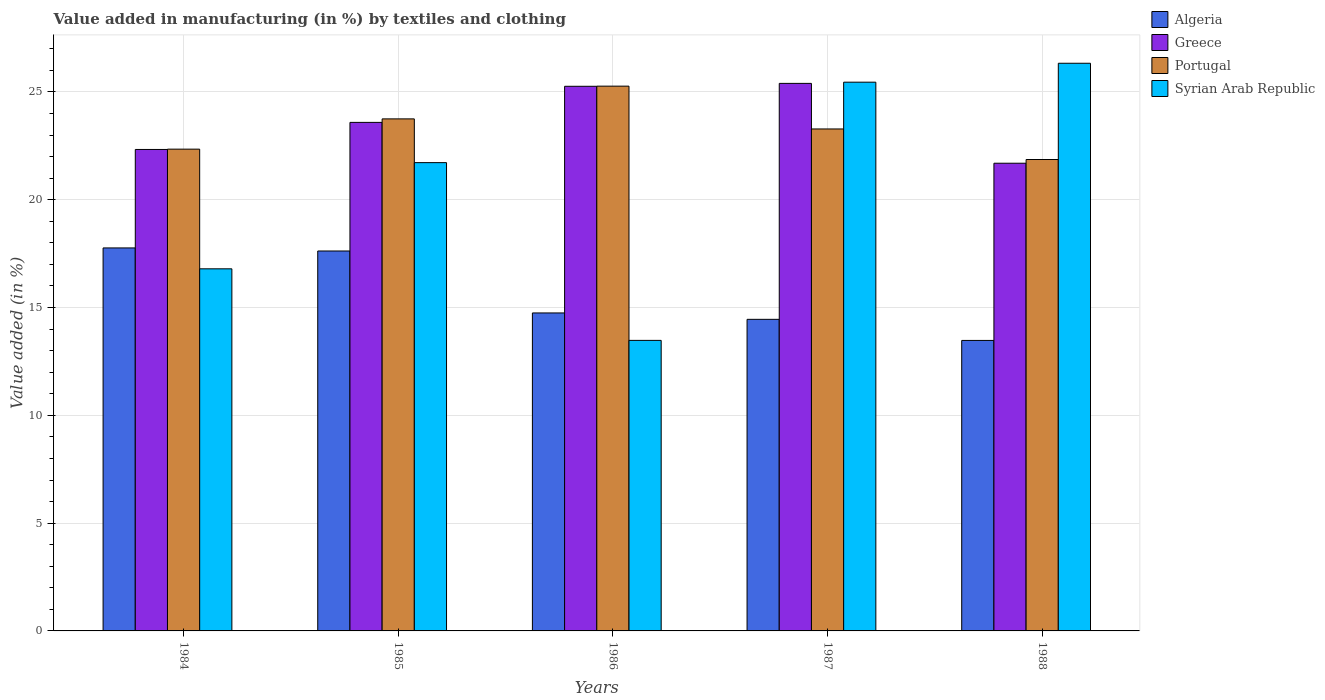How many different coloured bars are there?
Offer a terse response. 4. How many groups of bars are there?
Make the answer very short. 5. Are the number of bars on each tick of the X-axis equal?
Your answer should be compact. Yes. How many bars are there on the 4th tick from the left?
Give a very brief answer. 4. In how many cases, is the number of bars for a given year not equal to the number of legend labels?
Give a very brief answer. 0. What is the percentage of value added in manufacturing by textiles and clothing in Syrian Arab Republic in 1987?
Your answer should be compact. 25.45. Across all years, what is the maximum percentage of value added in manufacturing by textiles and clothing in Greece?
Offer a very short reply. 25.4. Across all years, what is the minimum percentage of value added in manufacturing by textiles and clothing in Greece?
Make the answer very short. 21.69. What is the total percentage of value added in manufacturing by textiles and clothing in Portugal in the graph?
Ensure brevity in your answer.  116.52. What is the difference between the percentage of value added in manufacturing by textiles and clothing in Portugal in 1985 and that in 1987?
Your answer should be very brief. 0.47. What is the difference between the percentage of value added in manufacturing by textiles and clothing in Greece in 1988 and the percentage of value added in manufacturing by textiles and clothing in Algeria in 1987?
Your answer should be compact. 7.24. What is the average percentage of value added in manufacturing by textiles and clothing in Syrian Arab Republic per year?
Make the answer very short. 20.76. In the year 1986, what is the difference between the percentage of value added in manufacturing by textiles and clothing in Greece and percentage of value added in manufacturing by textiles and clothing in Portugal?
Offer a very short reply. -0.01. In how many years, is the percentage of value added in manufacturing by textiles and clothing in Portugal greater than 18 %?
Offer a very short reply. 5. What is the ratio of the percentage of value added in manufacturing by textiles and clothing in Algeria in 1984 to that in 1988?
Your answer should be compact. 1.32. Is the difference between the percentage of value added in manufacturing by textiles and clothing in Greece in 1986 and 1988 greater than the difference between the percentage of value added in manufacturing by textiles and clothing in Portugal in 1986 and 1988?
Your response must be concise. Yes. What is the difference between the highest and the second highest percentage of value added in manufacturing by textiles and clothing in Portugal?
Your response must be concise. 1.52. What is the difference between the highest and the lowest percentage of value added in manufacturing by textiles and clothing in Greece?
Offer a very short reply. 3.7. In how many years, is the percentage of value added in manufacturing by textiles and clothing in Greece greater than the average percentage of value added in manufacturing by textiles and clothing in Greece taken over all years?
Make the answer very short. 2. What does the 3rd bar from the right in 1988 represents?
Keep it short and to the point. Greece. Is it the case that in every year, the sum of the percentage of value added in manufacturing by textiles and clothing in Portugal and percentage of value added in manufacturing by textiles and clothing in Greece is greater than the percentage of value added in manufacturing by textiles and clothing in Syrian Arab Republic?
Your answer should be very brief. Yes. Are all the bars in the graph horizontal?
Offer a very short reply. No. Where does the legend appear in the graph?
Give a very brief answer. Top right. What is the title of the graph?
Offer a very short reply. Value added in manufacturing (in %) by textiles and clothing. Does "Central Europe" appear as one of the legend labels in the graph?
Provide a succinct answer. No. What is the label or title of the X-axis?
Ensure brevity in your answer.  Years. What is the label or title of the Y-axis?
Offer a terse response. Value added (in %). What is the Value added (in %) in Algeria in 1984?
Ensure brevity in your answer.  17.76. What is the Value added (in %) in Greece in 1984?
Give a very brief answer. 22.33. What is the Value added (in %) in Portugal in 1984?
Your answer should be compact. 22.35. What is the Value added (in %) of Syrian Arab Republic in 1984?
Provide a short and direct response. 16.8. What is the Value added (in %) of Algeria in 1985?
Offer a terse response. 17.62. What is the Value added (in %) in Greece in 1985?
Make the answer very short. 23.59. What is the Value added (in %) in Portugal in 1985?
Keep it short and to the point. 23.75. What is the Value added (in %) of Syrian Arab Republic in 1985?
Your answer should be compact. 21.72. What is the Value added (in %) of Algeria in 1986?
Provide a short and direct response. 14.75. What is the Value added (in %) in Greece in 1986?
Make the answer very short. 25.26. What is the Value added (in %) of Portugal in 1986?
Keep it short and to the point. 25.27. What is the Value added (in %) of Syrian Arab Republic in 1986?
Your answer should be very brief. 13.48. What is the Value added (in %) in Algeria in 1987?
Ensure brevity in your answer.  14.45. What is the Value added (in %) of Greece in 1987?
Offer a terse response. 25.4. What is the Value added (in %) of Portugal in 1987?
Offer a terse response. 23.28. What is the Value added (in %) of Syrian Arab Republic in 1987?
Offer a very short reply. 25.45. What is the Value added (in %) of Algeria in 1988?
Your answer should be very brief. 13.47. What is the Value added (in %) of Greece in 1988?
Your answer should be very brief. 21.69. What is the Value added (in %) in Portugal in 1988?
Ensure brevity in your answer.  21.87. What is the Value added (in %) of Syrian Arab Republic in 1988?
Keep it short and to the point. 26.33. Across all years, what is the maximum Value added (in %) in Algeria?
Keep it short and to the point. 17.76. Across all years, what is the maximum Value added (in %) of Greece?
Keep it short and to the point. 25.4. Across all years, what is the maximum Value added (in %) of Portugal?
Make the answer very short. 25.27. Across all years, what is the maximum Value added (in %) in Syrian Arab Republic?
Provide a succinct answer. 26.33. Across all years, what is the minimum Value added (in %) of Algeria?
Provide a succinct answer. 13.47. Across all years, what is the minimum Value added (in %) of Greece?
Provide a succinct answer. 21.69. Across all years, what is the minimum Value added (in %) of Portugal?
Make the answer very short. 21.87. Across all years, what is the minimum Value added (in %) of Syrian Arab Republic?
Offer a very short reply. 13.48. What is the total Value added (in %) in Algeria in the graph?
Provide a succinct answer. 78.06. What is the total Value added (in %) of Greece in the graph?
Your answer should be compact. 118.27. What is the total Value added (in %) in Portugal in the graph?
Keep it short and to the point. 116.52. What is the total Value added (in %) of Syrian Arab Republic in the graph?
Offer a very short reply. 103.78. What is the difference between the Value added (in %) in Algeria in 1984 and that in 1985?
Make the answer very short. 0.14. What is the difference between the Value added (in %) of Greece in 1984 and that in 1985?
Ensure brevity in your answer.  -1.26. What is the difference between the Value added (in %) of Portugal in 1984 and that in 1985?
Offer a very short reply. -1.4. What is the difference between the Value added (in %) of Syrian Arab Republic in 1984 and that in 1985?
Provide a succinct answer. -4.93. What is the difference between the Value added (in %) of Algeria in 1984 and that in 1986?
Give a very brief answer. 3.02. What is the difference between the Value added (in %) in Greece in 1984 and that in 1986?
Your response must be concise. -2.93. What is the difference between the Value added (in %) of Portugal in 1984 and that in 1986?
Provide a short and direct response. -2.92. What is the difference between the Value added (in %) in Syrian Arab Republic in 1984 and that in 1986?
Keep it short and to the point. 3.32. What is the difference between the Value added (in %) in Algeria in 1984 and that in 1987?
Provide a succinct answer. 3.31. What is the difference between the Value added (in %) of Greece in 1984 and that in 1987?
Your answer should be compact. -3.06. What is the difference between the Value added (in %) of Portugal in 1984 and that in 1987?
Ensure brevity in your answer.  -0.94. What is the difference between the Value added (in %) of Syrian Arab Republic in 1984 and that in 1987?
Keep it short and to the point. -8.66. What is the difference between the Value added (in %) of Algeria in 1984 and that in 1988?
Your answer should be very brief. 4.29. What is the difference between the Value added (in %) in Greece in 1984 and that in 1988?
Provide a succinct answer. 0.64. What is the difference between the Value added (in %) of Portugal in 1984 and that in 1988?
Ensure brevity in your answer.  0.48. What is the difference between the Value added (in %) of Syrian Arab Republic in 1984 and that in 1988?
Ensure brevity in your answer.  -9.53. What is the difference between the Value added (in %) of Algeria in 1985 and that in 1986?
Your response must be concise. 2.87. What is the difference between the Value added (in %) in Greece in 1985 and that in 1986?
Offer a very short reply. -1.67. What is the difference between the Value added (in %) in Portugal in 1985 and that in 1986?
Your answer should be very brief. -1.52. What is the difference between the Value added (in %) in Syrian Arab Republic in 1985 and that in 1986?
Provide a short and direct response. 8.24. What is the difference between the Value added (in %) in Algeria in 1985 and that in 1987?
Your answer should be very brief. 3.17. What is the difference between the Value added (in %) of Greece in 1985 and that in 1987?
Keep it short and to the point. -1.81. What is the difference between the Value added (in %) of Portugal in 1985 and that in 1987?
Make the answer very short. 0.47. What is the difference between the Value added (in %) of Syrian Arab Republic in 1985 and that in 1987?
Your response must be concise. -3.73. What is the difference between the Value added (in %) of Algeria in 1985 and that in 1988?
Provide a succinct answer. 4.15. What is the difference between the Value added (in %) of Greece in 1985 and that in 1988?
Your answer should be compact. 1.89. What is the difference between the Value added (in %) in Portugal in 1985 and that in 1988?
Offer a very short reply. 1.88. What is the difference between the Value added (in %) of Syrian Arab Republic in 1985 and that in 1988?
Your answer should be compact. -4.61. What is the difference between the Value added (in %) in Algeria in 1986 and that in 1987?
Keep it short and to the point. 0.3. What is the difference between the Value added (in %) of Greece in 1986 and that in 1987?
Offer a very short reply. -0.13. What is the difference between the Value added (in %) of Portugal in 1986 and that in 1987?
Provide a succinct answer. 1.99. What is the difference between the Value added (in %) in Syrian Arab Republic in 1986 and that in 1987?
Your response must be concise. -11.98. What is the difference between the Value added (in %) in Algeria in 1986 and that in 1988?
Offer a terse response. 1.27. What is the difference between the Value added (in %) of Greece in 1986 and that in 1988?
Give a very brief answer. 3.57. What is the difference between the Value added (in %) in Portugal in 1986 and that in 1988?
Your answer should be very brief. 3.4. What is the difference between the Value added (in %) of Syrian Arab Republic in 1986 and that in 1988?
Your answer should be compact. -12.85. What is the difference between the Value added (in %) of Algeria in 1987 and that in 1988?
Your answer should be very brief. 0.98. What is the difference between the Value added (in %) in Greece in 1987 and that in 1988?
Give a very brief answer. 3.7. What is the difference between the Value added (in %) of Portugal in 1987 and that in 1988?
Give a very brief answer. 1.42. What is the difference between the Value added (in %) in Syrian Arab Republic in 1987 and that in 1988?
Offer a terse response. -0.88. What is the difference between the Value added (in %) in Algeria in 1984 and the Value added (in %) in Greece in 1985?
Offer a terse response. -5.82. What is the difference between the Value added (in %) in Algeria in 1984 and the Value added (in %) in Portugal in 1985?
Offer a very short reply. -5.99. What is the difference between the Value added (in %) in Algeria in 1984 and the Value added (in %) in Syrian Arab Republic in 1985?
Provide a succinct answer. -3.96. What is the difference between the Value added (in %) of Greece in 1984 and the Value added (in %) of Portugal in 1985?
Offer a terse response. -1.42. What is the difference between the Value added (in %) in Greece in 1984 and the Value added (in %) in Syrian Arab Republic in 1985?
Make the answer very short. 0.61. What is the difference between the Value added (in %) in Portugal in 1984 and the Value added (in %) in Syrian Arab Republic in 1985?
Keep it short and to the point. 0.63. What is the difference between the Value added (in %) in Algeria in 1984 and the Value added (in %) in Greece in 1986?
Provide a succinct answer. -7.5. What is the difference between the Value added (in %) in Algeria in 1984 and the Value added (in %) in Portugal in 1986?
Offer a terse response. -7.5. What is the difference between the Value added (in %) in Algeria in 1984 and the Value added (in %) in Syrian Arab Republic in 1986?
Give a very brief answer. 4.29. What is the difference between the Value added (in %) in Greece in 1984 and the Value added (in %) in Portugal in 1986?
Give a very brief answer. -2.94. What is the difference between the Value added (in %) in Greece in 1984 and the Value added (in %) in Syrian Arab Republic in 1986?
Ensure brevity in your answer.  8.86. What is the difference between the Value added (in %) of Portugal in 1984 and the Value added (in %) of Syrian Arab Republic in 1986?
Keep it short and to the point. 8.87. What is the difference between the Value added (in %) of Algeria in 1984 and the Value added (in %) of Greece in 1987?
Give a very brief answer. -7.63. What is the difference between the Value added (in %) in Algeria in 1984 and the Value added (in %) in Portugal in 1987?
Ensure brevity in your answer.  -5.52. What is the difference between the Value added (in %) in Algeria in 1984 and the Value added (in %) in Syrian Arab Republic in 1987?
Your answer should be compact. -7.69. What is the difference between the Value added (in %) in Greece in 1984 and the Value added (in %) in Portugal in 1987?
Ensure brevity in your answer.  -0.95. What is the difference between the Value added (in %) of Greece in 1984 and the Value added (in %) of Syrian Arab Republic in 1987?
Keep it short and to the point. -3.12. What is the difference between the Value added (in %) in Portugal in 1984 and the Value added (in %) in Syrian Arab Republic in 1987?
Keep it short and to the point. -3.11. What is the difference between the Value added (in %) of Algeria in 1984 and the Value added (in %) of Greece in 1988?
Ensure brevity in your answer.  -3.93. What is the difference between the Value added (in %) in Algeria in 1984 and the Value added (in %) in Portugal in 1988?
Make the answer very short. -4.1. What is the difference between the Value added (in %) in Algeria in 1984 and the Value added (in %) in Syrian Arab Republic in 1988?
Offer a very short reply. -8.57. What is the difference between the Value added (in %) of Greece in 1984 and the Value added (in %) of Portugal in 1988?
Give a very brief answer. 0.47. What is the difference between the Value added (in %) in Greece in 1984 and the Value added (in %) in Syrian Arab Republic in 1988?
Your answer should be very brief. -4. What is the difference between the Value added (in %) of Portugal in 1984 and the Value added (in %) of Syrian Arab Republic in 1988?
Your answer should be very brief. -3.98. What is the difference between the Value added (in %) in Algeria in 1985 and the Value added (in %) in Greece in 1986?
Your response must be concise. -7.64. What is the difference between the Value added (in %) in Algeria in 1985 and the Value added (in %) in Portugal in 1986?
Keep it short and to the point. -7.65. What is the difference between the Value added (in %) of Algeria in 1985 and the Value added (in %) of Syrian Arab Republic in 1986?
Provide a succinct answer. 4.15. What is the difference between the Value added (in %) of Greece in 1985 and the Value added (in %) of Portugal in 1986?
Give a very brief answer. -1.68. What is the difference between the Value added (in %) of Greece in 1985 and the Value added (in %) of Syrian Arab Republic in 1986?
Provide a short and direct response. 10.11. What is the difference between the Value added (in %) of Portugal in 1985 and the Value added (in %) of Syrian Arab Republic in 1986?
Ensure brevity in your answer.  10.27. What is the difference between the Value added (in %) in Algeria in 1985 and the Value added (in %) in Greece in 1987?
Ensure brevity in your answer.  -7.77. What is the difference between the Value added (in %) in Algeria in 1985 and the Value added (in %) in Portugal in 1987?
Offer a terse response. -5.66. What is the difference between the Value added (in %) of Algeria in 1985 and the Value added (in %) of Syrian Arab Republic in 1987?
Provide a succinct answer. -7.83. What is the difference between the Value added (in %) of Greece in 1985 and the Value added (in %) of Portugal in 1987?
Your answer should be compact. 0.3. What is the difference between the Value added (in %) of Greece in 1985 and the Value added (in %) of Syrian Arab Republic in 1987?
Your response must be concise. -1.86. What is the difference between the Value added (in %) of Portugal in 1985 and the Value added (in %) of Syrian Arab Republic in 1987?
Your response must be concise. -1.7. What is the difference between the Value added (in %) of Algeria in 1985 and the Value added (in %) of Greece in 1988?
Give a very brief answer. -4.07. What is the difference between the Value added (in %) of Algeria in 1985 and the Value added (in %) of Portugal in 1988?
Give a very brief answer. -4.24. What is the difference between the Value added (in %) of Algeria in 1985 and the Value added (in %) of Syrian Arab Republic in 1988?
Give a very brief answer. -8.71. What is the difference between the Value added (in %) in Greece in 1985 and the Value added (in %) in Portugal in 1988?
Give a very brief answer. 1.72. What is the difference between the Value added (in %) of Greece in 1985 and the Value added (in %) of Syrian Arab Republic in 1988?
Keep it short and to the point. -2.74. What is the difference between the Value added (in %) of Portugal in 1985 and the Value added (in %) of Syrian Arab Republic in 1988?
Ensure brevity in your answer.  -2.58. What is the difference between the Value added (in %) of Algeria in 1986 and the Value added (in %) of Greece in 1987?
Offer a terse response. -10.65. What is the difference between the Value added (in %) of Algeria in 1986 and the Value added (in %) of Portugal in 1987?
Your answer should be very brief. -8.53. What is the difference between the Value added (in %) of Algeria in 1986 and the Value added (in %) of Syrian Arab Republic in 1987?
Give a very brief answer. -10.7. What is the difference between the Value added (in %) in Greece in 1986 and the Value added (in %) in Portugal in 1987?
Your answer should be compact. 1.98. What is the difference between the Value added (in %) of Greece in 1986 and the Value added (in %) of Syrian Arab Republic in 1987?
Give a very brief answer. -0.19. What is the difference between the Value added (in %) in Portugal in 1986 and the Value added (in %) in Syrian Arab Republic in 1987?
Your answer should be very brief. -0.18. What is the difference between the Value added (in %) in Algeria in 1986 and the Value added (in %) in Greece in 1988?
Give a very brief answer. -6.94. What is the difference between the Value added (in %) of Algeria in 1986 and the Value added (in %) of Portugal in 1988?
Your answer should be very brief. -7.12. What is the difference between the Value added (in %) of Algeria in 1986 and the Value added (in %) of Syrian Arab Republic in 1988?
Your response must be concise. -11.58. What is the difference between the Value added (in %) in Greece in 1986 and the Value added (in %) in Portugal in 1988?
Keep it short and to the point. 3.4. What is the difference between the Value added (in %) in Greece in 1986 and the Value added (in %) in Syrian Arab Republic in 1988?
Make the answer very short. -1.07. What is the difference between the Value added (in %) of Portugal in 1986 and the Value added (in %) of Syrian Arab Republic in 1988?
Your answer should be compact. -1.06. What is the difference between the Value added (in %) of Algeria in 1987 and the Value added (in %) of Greece in 1988?
Keep it short and to the point. -7.24. What is the difference between the Value added (in %) in Algeria in 1987 and the Value added (in %) in Portugal in 1988?
Offer a very short reply. -7.41. What is the difference between the Value added (in %) in Algeria in 1987 and the Value added (in %) in Syrian Arab Republic in 1988?
Ensure brevity in your answer.  -11.88. What is the difference between the Value added (in %) in Greece in 1987 and the Value added (in %) in Portugal in 1988?
Your answer should be compact. 3.53. What is the difference between the Value added (in %) of Greece in 1987 and the Value added (in %) of Syrian Arab Republic in 1988?
Ensure brevity in your answer.  -0.93. What is the difference between the Value added (in %) of Portugal in 1987 and the Value added (in %) of Syrian Arab Republic in 1988?
Give a very brief answer. -3.05. What is the average Value added (in %) in Algeria per year?
Keep it short and to the point. 15.61. What is the average Value added (in %) in Greece per year?
Your answer should be very brief. 23.65. What is the average Value added (in %) in Portugal per year?
Your answer should be compact. 23.3. What is the average Value added (in %) of Syrian Arab Republic per year?
Offer a terse response. 20.76. In the year 1984, what is the difference between the Value added (in %) of Algeria and Value added (in %) of Greece?
Give a very brief answer. -4.57. In the year 1984, what is the difference between the Value added (in %) of Algeria and Value added (in %) of Portugal?
Give a very brief answer. -4.58. In the year 1984, what is the difference between the Value added (in %) of Greece and Value added (in %) of Portugal?
Offer a very short reply. -0.01. In the year 1984, what is the difference between the Value added (in %) in Greece and Value added (in %) in Syrian Arab Republic?
Provide a succinct answer. 5.54. In the year 1984, what is the difference between the Value added (in %) of Portugal and Value added (in %) of Syrian Arab Republic?
Provide a succinct answer. 5.55. In the year 1985, what is the difference between the Value added (in %) in Algeria and Value added (in %) in Greece?
Offer a terse response. -5.97. In the year 1985, what is the difference between the Value added (in %) in Algeria and Value added (in %) in Portugal?
Your response must be concise. -6.13. In the year 1985, what is the difference between the Value added (in %) of Algeria and Value added (in %) of Syrian Arab Republic?
Provide a short and direct response. -4.1. In the year 1985, what is the difference between the Value added (in %) of Greece and Value added (in %) of Portugal?
Ensure brevity in your answer.  -0.16. In the year 1985, what is the difference between the Value added (in %) in Greece and Value added (in %) in Syrian Arab Republic?
Provide a succinct answer. 1.87. In the year 1985, what is the difference between the Value added (in %) in Portugal and Value added (in %) in Syrian Arab Republic?
Offer a terse response. 2.03. In the year 1986, what is the difference between the Value added (in %) of Algeria and Value added (in %) of Greece?
Ensure brevity in your answer.  -10.51. In the year 1986, what is the difference between the Value added (in %) of Algeria and Value added (in %) of Portugal?
Keep it short and to the point. -10.52. In the year 1986, what is the difference between the Value added (in %) of Algeria and Value added (in %) of Syrian Arab Republic?
Provide a succinct answer. 1.27. In the year 1986, what is the difference between the Value added (in %) in Greece and Value added (in %) in Portugal?
Ensure brevity in your answer.  -0.01. In the year 1986, what is the difference between the Value added (in %) in Greece and Value added (in %) in Syrian Arab Republic?
Offer a terse response. 11.79. In the year 1986, what is the difference between the Value added (in %) of Portugal and Value added (in %) of Syrian Arab Republic?
Your answer should be compact. 11.79. In the year 1987, what is the difference between the Value added (in %) of Algeria and Value added (in %) of Greece?
Your answer should be very brief. -10.94. In the year 1987, what is the difference between the Value added (in %) of Algeria and Value added (in %) of Portugal?
Provide a succinct answer. -8.83. In the year 1987, what is the difference between the Value added (in %) of Algeria and Value added (in %) of Syrian Arab Republic?
Provide a short and direct response. -11. In the year 1987, what is the difference between the Value added (in %) in Greece and Value added (in %) in Portugal?
Give a very brief answer. 2.11. In the year 1987, what is the difference between the Value added (in %) in Greece and Value added (in %) in Syrian Arab Republic?
Give a very brief answer. -0.06. In the year 1987, what is the difference between the Value added (in %) of Portugal and Value added (in %) of Syrian Arab Republic?
Make the answer very short. -2.17. In the year 1988, what is the difference between the Value added (in %) in Algeria and Value added (in %) in Greece?
Provide a short and direct response. -8.22. In the year 1988, what is the difference between the Value added (in %) of Algeria and Value added (in %) of Portugal?
Provide a short and direct response. -8.39. In the year 1988, what is the difference between the Value added (in %) of Algeria and Value added (in %) of Syrian Arab Republic?
Give a very brief answer. -12.86. In the year 1988, what is the difference between the Value added (in %) in Greece and Value added (in %) in Portugal?
Ensure brevity in your answer.  -0.17. In the year 1988, what is the difference between the Value added (in %) in Greece and Value added (in %) in Syrian Arab Republic?
Make the answer very short. -4.64. In the year 1988, what is the difference between the Value added (in %) in Portugal and Value added (in %) in Syrian Arab Republic?
Your answer should be very brief. -4.46. What is the ratio of the Value added (in %) in Greece in 1984 to that in 1985?
Offer a very short reply. 0.95. What is the ratio of the Value added (in %) of Portugal in 1984 to that in 1985?
Your response must be concise. 0.94. What is the ratio of the Value added (in %) in Syrian Arab Republic in 1984 to that in 1985?
Offer a terse response. 0.77. What is the ratio of the Value added (in %) of Algeria in 1984 to that in 1986?
Make the answer very short. 1.2. What is the ratio of the Value added (in %) in Greece in 1984 to that in 1986?
Provide a short and direct response. 0.88. What is the ratio of the Value added (in %) in Portugal in 1984 to that in 1986?
Ensure brevity in your answer.  0.88. What is the ratio of the Value added (in %) of Syrian Arab Republic in 1984 to that in 1986?
Provide a short and direct response. 1.25. What is the ratio of the Value added (in %) in Algeria in 1984 to that in 1987?
Your answer should be compact. 1.23. What is the ratio of the Value added (in %) in Greece in 1984 to that in 1987?
Offer a very short reply. 0.88. What is the ratio of the Value added (in %) in Portugal in 1984 to that in 1987?
Ensure brevity in your answer.  0.96. What is the ratio of the Value added (in %) in Syrian Arab Republic in 1984 to that in 1987?
Provide a short and direct response. 0.66. What is the ratio of the Value added (in %) in Algeria in 1984 to that in 1988?
Give a very brief answer. 1.32. What is the ratio of the Value added (in %) of Greece in 1984 to that in 1988?
Provide a succinct answer. 1.03. What is the ratio of the Value added (in %) of Syrian Arab Republic in 1984 to that in 1988?
Ensure brevity in your answer.  0.64. What is the ratio of the Value added (in %) in Algeria in 1985 to that in 1986?
Keep it short and to the point. 1.19. What is the ratio of the Value added (in %) of Greece in 1985 to that in 1986?
Offer a terse response. 0.93. What is the ratio of the Value added (in %) in Portugal in 1985 to that in 1986?
Offer a very short reply. 0.94. What is the ratio of the Value added (in %) in Syrian Arab Republic in 1985 to that in 1986?
Offer a very short reply. 1.61. What is the ratio of the Value added (in %) of Algeria in 1985 to that in 1987?
Offer a very short reply. 1.22. What is the ratio of the Value added (in %) of Greece in 1985 to that in 1987?
Offer a terse response. 0.93. What is the ratio of the Value added (in %) of Portugal in 1985 to that in 1987?
Make the answer very short. 1.02. What is the ratio of the Value added (in %) of Syrian Arab Republic in 1985 to that in 1987?
Provide a short and direct response. 0.85. What is the ratio of the Value added (in %) in Algeria in 1985 to that in 1988?
Provide a short and direct response. 1.31. What is the ratio of the Value added (in %) of Greece in 1985 to that in 1988?
Provide a succinct answer. 1.09. What is the ratio of the Value added (in %) of Portugal in 1985 to that in 1988?
Provide a succinct answer. 1.09. What is the ratio of the Value added (in %) of Syrian Arab Republic in 1985 to that in 1988?
Ensure brevity in your answer.  0.82. What is the ratio of the Value added (in %) in Algeria in 1986 to that in 1987?
Ensure brevity in your answer.  1.02. What is the ratio of the Value added (in %) in Portugal in 1986 to that in 1987?
Your answer should be very brief. 1.09. What is the ratio of the Value added (in %) of Syrian Arab Republic in 1986 to that in 1987?
Provide a short and direct response. 0.53. What is the ratio of the Value added (in %) in Algeria in 1986 to that in 1988?
Your answer should be very brief. 1.09. What is the ratio of the Value added (in %) in Greece in 1986 to that in 1988?
Your answer should be very brief. 1.16. What is the ratio of the Value added (in %) of Portugal in 1986 to that in 1988?
Make the answer very short. 1.16. What is the ratio of the Value added (in %) of Syrian Arab Republic in 1986 to that in 1988?
Give a very brief answer. 0.51. What is the ratio of the Value added (in %) in Algeria in 1987 to that in 1988?
Ensure brevity in your answer.  1.07. What is the ratio of the Value added (in %) of Greece in 1987 to that in 1988?
Your answer should be compact. 1.17. What is the ratio of the Value added (in %) in Portugal in 1987 to that in 1988?
Offer a terse response. 1.06. What is the ratio of the Value added (in %) of Syrian Arab Republic in 1987 to that in 1988?
Offer a terse response. 0.97. What is the difference between the highest and the second highest Value added (in %) of Algeria?
Your answer should be very brief. 0.14. What is the difference between the highest and the second highest Value added (in %) in Greece?
Ensure brevity in your answer.  0.13. What is the difference between the highest and the second highest Value added (in %) in Portugal?
Offer a very short reply. 1.52. What is the difference between the highest and the second highest Value added (in %) in Syrian Arab Republic?
Make the answer very short. 0.88. What is the difference between the highest and the lowest Value added (in %) of Algeria?
Ensure brevity in your answer.  4.29. What is the difference between the highest and the lowest Value added (in %) in Greece?
Make the answer very short. 3.7. What is the difference between the highest and the lowest Value added (in %) in Portugal?
Provide a short and direct response. 3.4. What is the difference between the highest and the lowest Value added (in %) of Syrian Arab Republic?
Give a very brief answer. 12.85. 